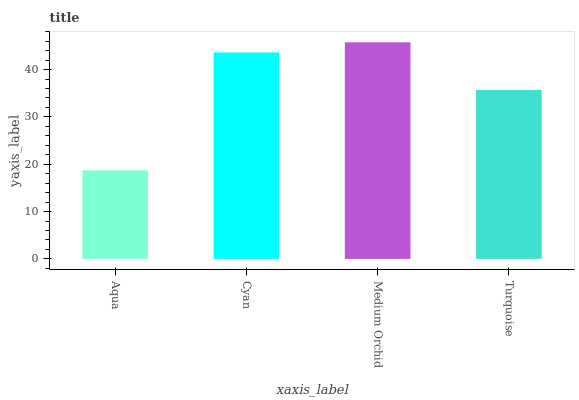Is Aqua the minimum?
Answer yes or no. Yes. Is Medium Orchid the maximum?
Answer yes or no. Yes. Is Cyan the minimum?
Answer yes or no. No. Is Cyan the maximum?
Answer yes or no. No. Is Cyan greater than Aqua?
Answer yes or no. Yes. Is Aqua less than Cyan?
Answer yes or no. Yes. Is Aqua greater than Cyan?
Answer yes or no. No. Is Cyan less than Aqua?
Answer yes or no. No. Is Cyan the high median?
Answer yes or no. Yes. Is Turquoise the low median?
Answer yes or no. Yes. Is Aqua the high median?
Answer yes or no. No. Is Aqua the low median?
Answer yes or no. No. 